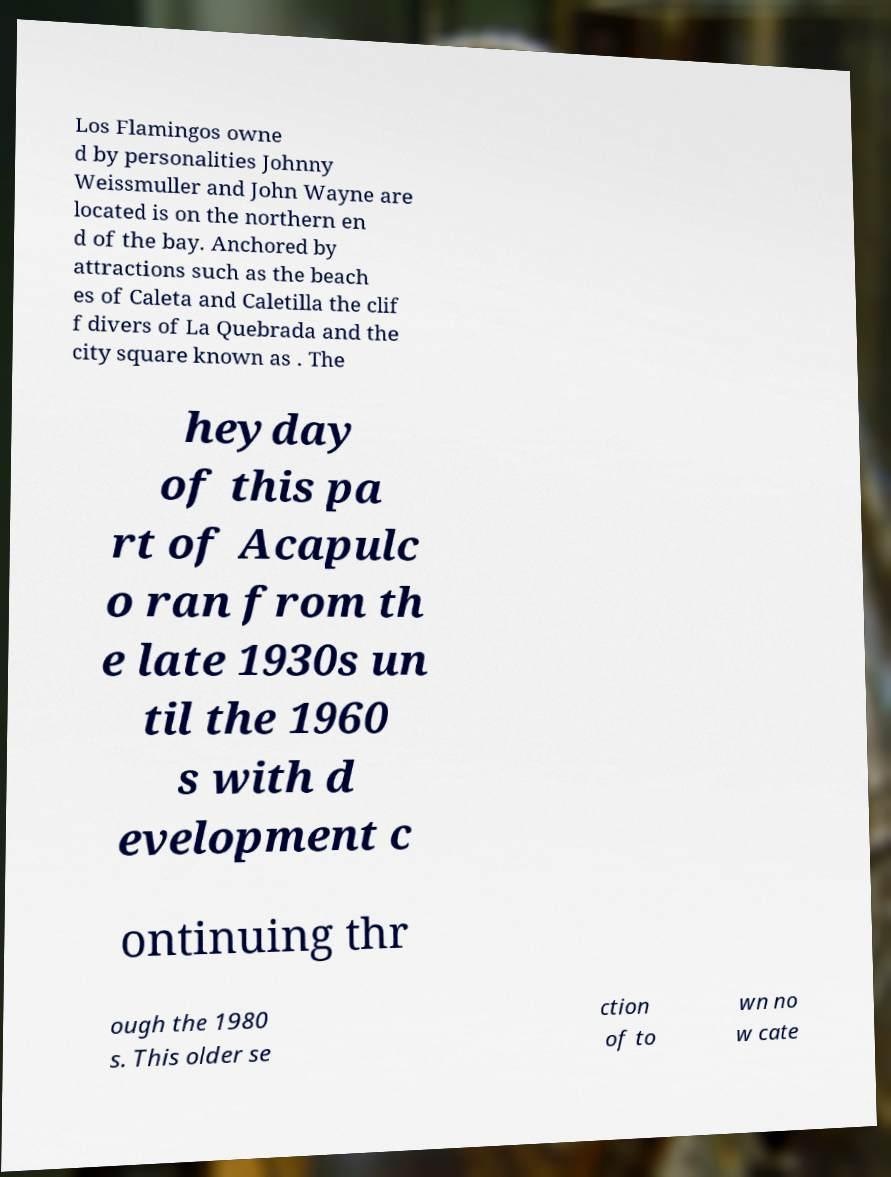Please identify and transcribe the text found in this image. Los Flamingos owne d by personalities Johnny Weissmuller and John Wayne are located is on the northern en d of the bay. Anchored by attractions such as the beach es of Caleta and Caletilla the clif f divers of La Quebrada and the city square known as . The heyday of this pa rt of Acapulc o ran from th e late 1930s un til the 1960 s with d evelopment c ontinuing thr ough the 1980 s. This older se ction of to wn no w cate 